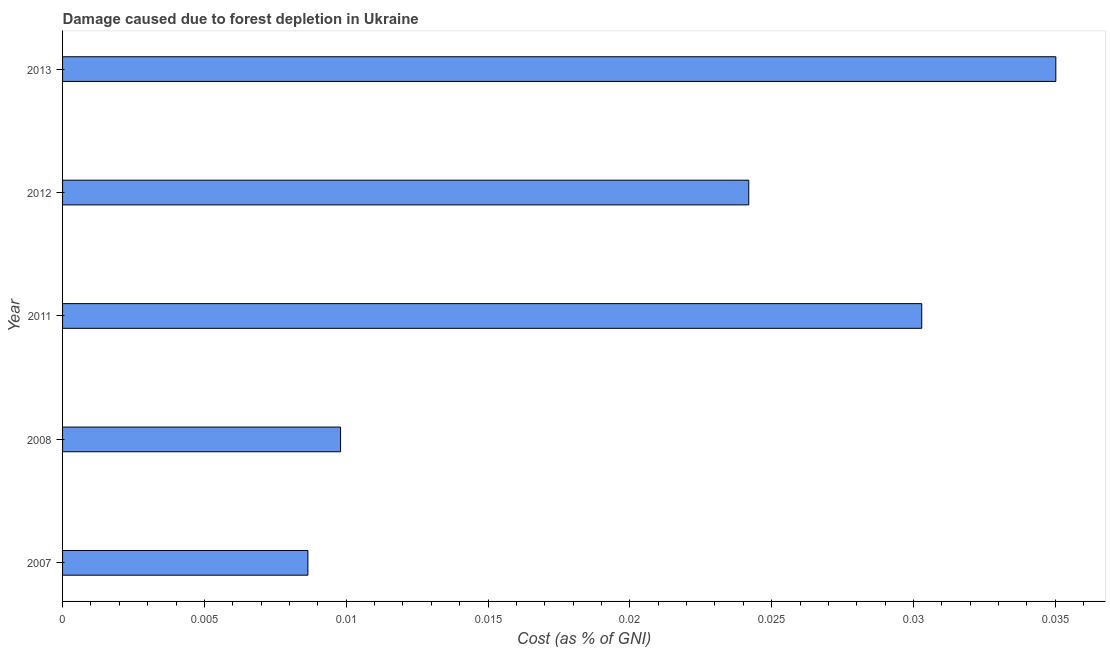What is the title of the graph?
Make the answer very short. Damage caused due to forest depletion in Ukraine. What is the label or title of the X-axis?
Ensure brevity in your answer.  Cost (as % of GNI). What is the damage caused due to forest depletion in 2012?
Offer a terse response. 0.02. Across all years, what is the maximum damage caused due to forest depletion?
Ensure brevity in your answer.  0.04. Across all years, what is the minimum damage caused due to forest depletion?
Provide a succinct answer. 0.01. In which year was the damage caused due to forest depletion maximum?
Make the answer very short. 2013. What is the sum of the damage caused due to forest depletion?
Keep it short and to the point. 0.11. What is the difference between the damage caused due to forest depletion in 2007 and 2011?
Your response must be concise. -0.02. What is the average damage caused due to forest depletion per year?
Give a very brief answer. 0.02. What is the median damage caused due to forest depletion?
Give a very brief answer. 0.02. What is the ratio of the damage caused due to forest depletion in 2008 to that in 2012?
Make the answer very short. 0.41. What is the difference between the highest and the second highest damage caused due to forest depletion?
Offer a terse response. 0.01. In how many years, is the damage caused due to forest depletion greater than the average damage caused due to forest depletion taken over all years?
Ensure brevity in your answer.  3. How many bars are there?
Offer a very short reply. 5. Are all the bars in the graph horizontal?
Offer a very short reply. Yes. What is the difference between two consecutive major ticks on the X-axis?
Your answer should be very brief. 0.01. Are the values on the major ticks of X-axis written in scientific E-notation?
Keep it short and to the point. No. What is the Cost (as % of GNI) of 2007?
Offer a very short reply. 0.01. What is the Cost (as % of GNI) of 2008?
Make the answer very short. 0.01. What is the Cost (as % of GNI) of 2011?
Offer a very short reply. 0.03. What is the Cost (as % of GNI) in 2012?
Offer a terse response. 0.02. What is the Cost (as % of GNI) of 2013?
Offer a terse response. 0.04. What is the difference between the Cost (as % of GNI) in 2007 and 2008?
Your answer should be compact. -0. What is the difference between the Cost (as % of GNI) in 2007 and 2011?
Offer a very short reply. -0.02. What is the difference between the Cost (as % of GNI) in 2007 and 2012?
Offer a very short reply. -0.02. What is the difference between the Cost (as % of GNI) in 2007 and 2013?
Ensure brevity in your answer.  -0.03. What is the difference between the Cost (as % of GNI) in 2008 and 2011?
Your response must be concise. -0.02. What is the difference between the Cost (as % of GNI) in 2008 and 2012?
Ensure brevity in your answer.  -0.01. What is the difference between the Cost (as % of GNI) in 2008 and 2013?
Offer a terse response. -0.03. What is the difference between the Cost (as % of GNI) in 2011 and 2012?
Provide a short and direct response. 0.01. What is the difference between the Cost (as % of GNI) in 2011 and 2013?
Offer a very short reply. -0. What is the difference between the Cost (as % of GNI) in 2012 and 2013?
Keep it short and to the point. -0.01. What is the ratio of the Cost (as % of GNI) in 2007 to that in 2008?
Offer a very short reply. 0.88. What is the ratio of the Cost (as % of GNI) in 2007 to that in 2011?
Offer a terse response. 0.29. What is the ratio of the Cost (as % of GNI) in 2007 to that in 2012?
Your response must be concise. 0.36. What is the ratio of the Cost (as % of GNI) in 2007 to that in 2013?
Provide a succinct answer. 0.25. What is the ratio of the Cost (as % of GNI) in 2008 to that in 2011?
Provide a succinct answer. 0.32. What is the ratio of the Cost (as % of GNI) in 2008 to that in 2012?
Provide a short and direct response. 0.41. What is the ratio of the Cost (as % of GNI) in 2008 to that in 2013?
Make the answer very short. 0.28. What is the ratio of the Cost (as % of GNI) in 2011 to that in 2012?
Your answer should be compact. 1.25. What is the ratio of the Cost (as % of GNI) in 2011 to that in 2013?
Provide a short and direct response. 0.86. What is the ratio of the Cost (as % of GNI) in 2012 to that in 2013?
Your answer should be compact. 0.69. 